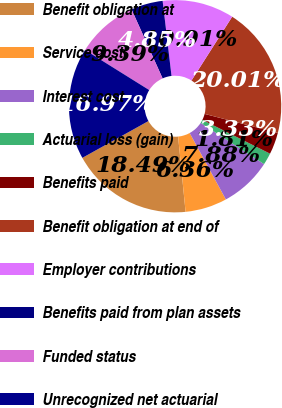Convert chart. <chart><loc_0><loc_0><loc_500><loc_500><pie_chart><fcel>Benefit obligation at<fcel>Service cost<fcel>Interest cost<fcel>Actuarial loss (gain)<fcel>Benefits paid<fcel>Benefit obligation at end of<fcel>Employer contributions<fcel>Benefits paid from plan assets<fcel>Funded status<fcel>Unrecognized net actuarial<nl><fcel>18.49%<fcel>6.36%<fcel>7.88%<fcel>1.81%<fcel>3.33%<fcel>20.01%<fcel>10.91%<fcel>4.85%<fcel>9.39%<fcel>16.97%<nl></chart> 